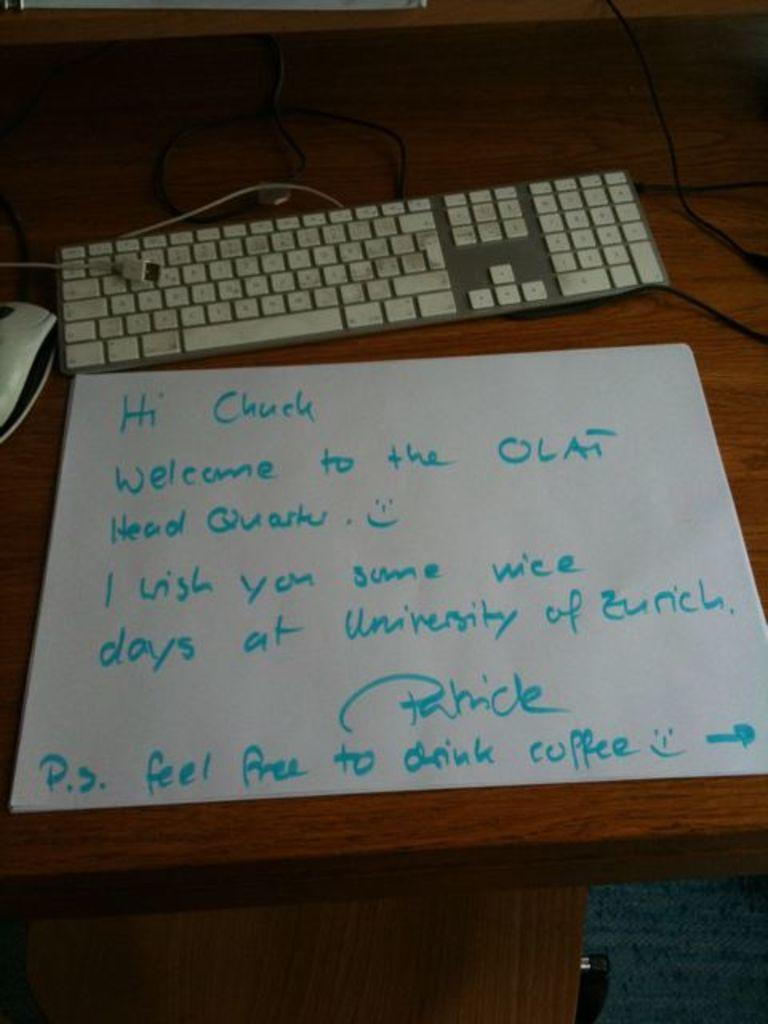What is the main object in the center of the image? There is a table in the center of the image. What electronic device is on the table? There is a keyboard on the table. What is used for controlling the cursor on the screen? There is a mouse on the table. What is placed on top of the table along with the keyboard and mouse? There is a paper on the table. What can be observed on the paper? There is writing on the paper. Where is the card located in the image? There is no card present in the image. Can you see any flowers or plants in the garden in the image? There is no garden present in the image. 